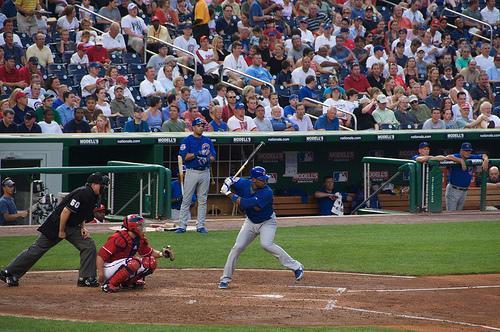How many players are holding a bat?
Give a very brief answer. 1. 